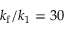Convert formula to latex. <formula><loc_0><loc_0><loc_500><loc_500>k _ { f } / k _ { 1 } = 3 0</formula> 